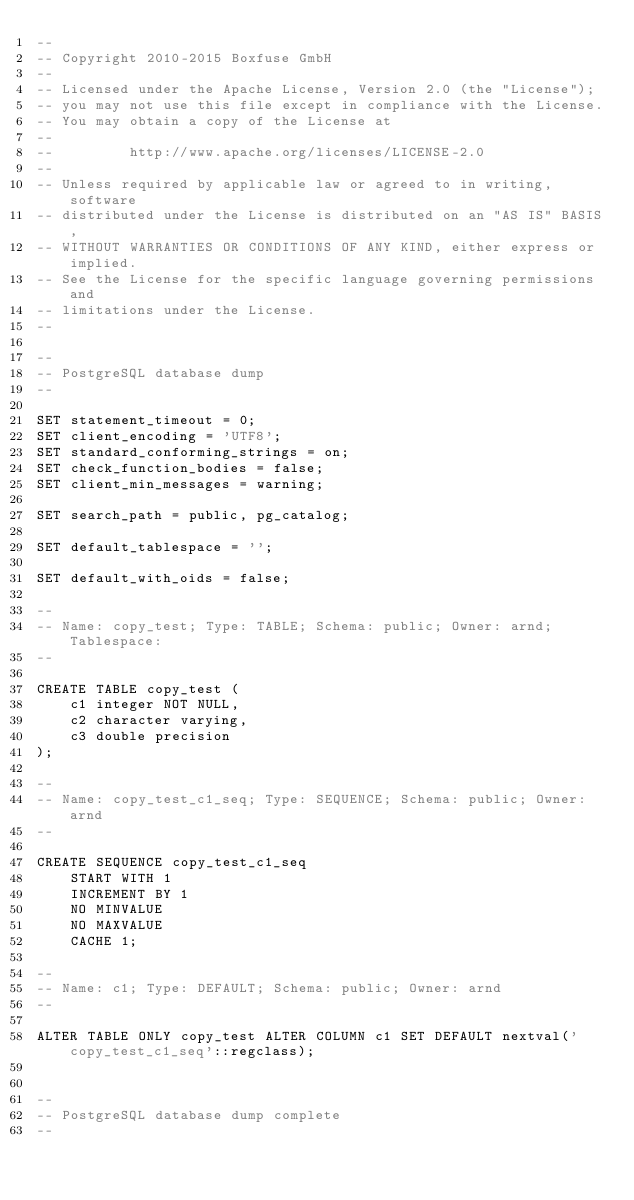<code> <loc_0><loc_0><loc_500><loc_500><_SQL_>--
-- Copyright 2010-2015 Boxfuse GmbH
--
-- Licensed under the Apache License, Version 2.0 (the "License");
-- you may not use this file except in compliance with the License.
-- You may obtain a copy of the License at
--
--         http://www.apache.org/licenses/LICENSE-2.0
--
-- Unless required by applicable law or agreed to in writing, software
-- distributed under the License is distributed on an "AS IS" BASIS,
-- WITHOUT WARRANTIES OR CONDITIONS OF ANY KIND, either express or implied.
-- See the License for the specific language governing permissions and
-- limitations under the License.
--

--
-- PostgreSQL database dump
--

SET statement_timeout = 0;
SET client_encoding = 'UTF8';
SET standard_conforming_strings = on;
SET check_function_bodies = false;
SET client_min_messages = warning;

SET search_path = public, pg_catalog;

SET default_tablespace = '';

SET default_with_oids = false;

--
-- Name: copy_test; Type: TABLE; Schema: public; Owner: arnd; Tablespace: 
--

CREATE TABLE copy_test (
    c1 integer NOT NULL,
    c2 character varying,
    c3 double precision
);

--
-- Name: copy_test_c1_seq; Type: SEQUENCE; Schema: public; Owner: arnd
--

CREATE SEQUENCE copy_test_c1_seq
    START WITH 1
    INCREMENT BY 1
    NO MINVALUE
    NO MAXVALUE
    CACHE 1;

--
-- Name: c1; Type: DEFAULT; Schema: public; Owner: arnd
--

ALTER TABLE ONLY copy_test ALTER COLUMN c1 SET DEFAULT nextval('copy_test_c1_seq'::regclass);


--
-- PostgreSQL database dump complete
--

</code> 